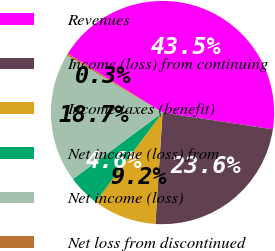Convert chart to OTSL. <chart><loc_0><loc_0><loc_500><loc_500><pie_chart><fcel>Revenues<fcel>Income (loss) from continuing<fcel>Income taxes (benefit)<fcel>Net income (loss) from<fcel>Net income (loss)<fcel>Net loss from discontinued<nl><fcel>43.54%<fcel>23.62%<fcel>9.21%<fcel>4.61%<fcel>18.73%<fcel>0.29%<nl></chart> 